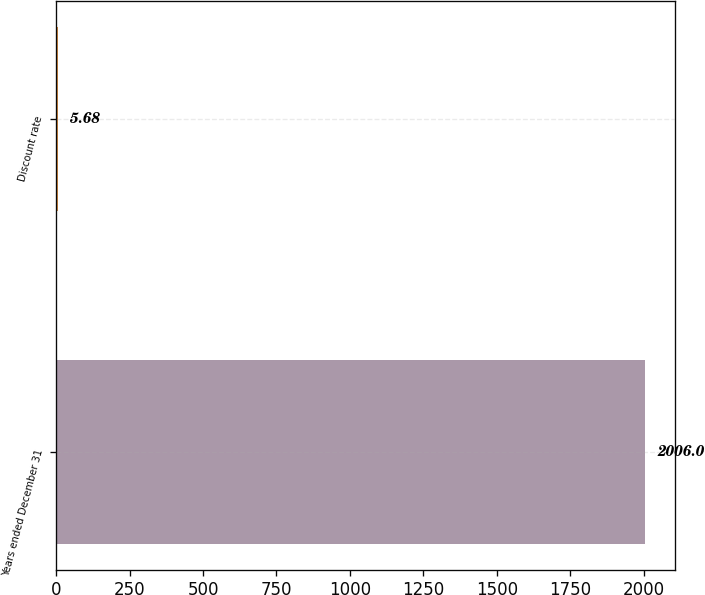<chart> <loc_0><loc_0><loc_500><loc_500><bar_chart><fcel>Years ended December 31<fcel>Discount rate<nl><fcel>2006<fcel>5.68<nl></chart> 